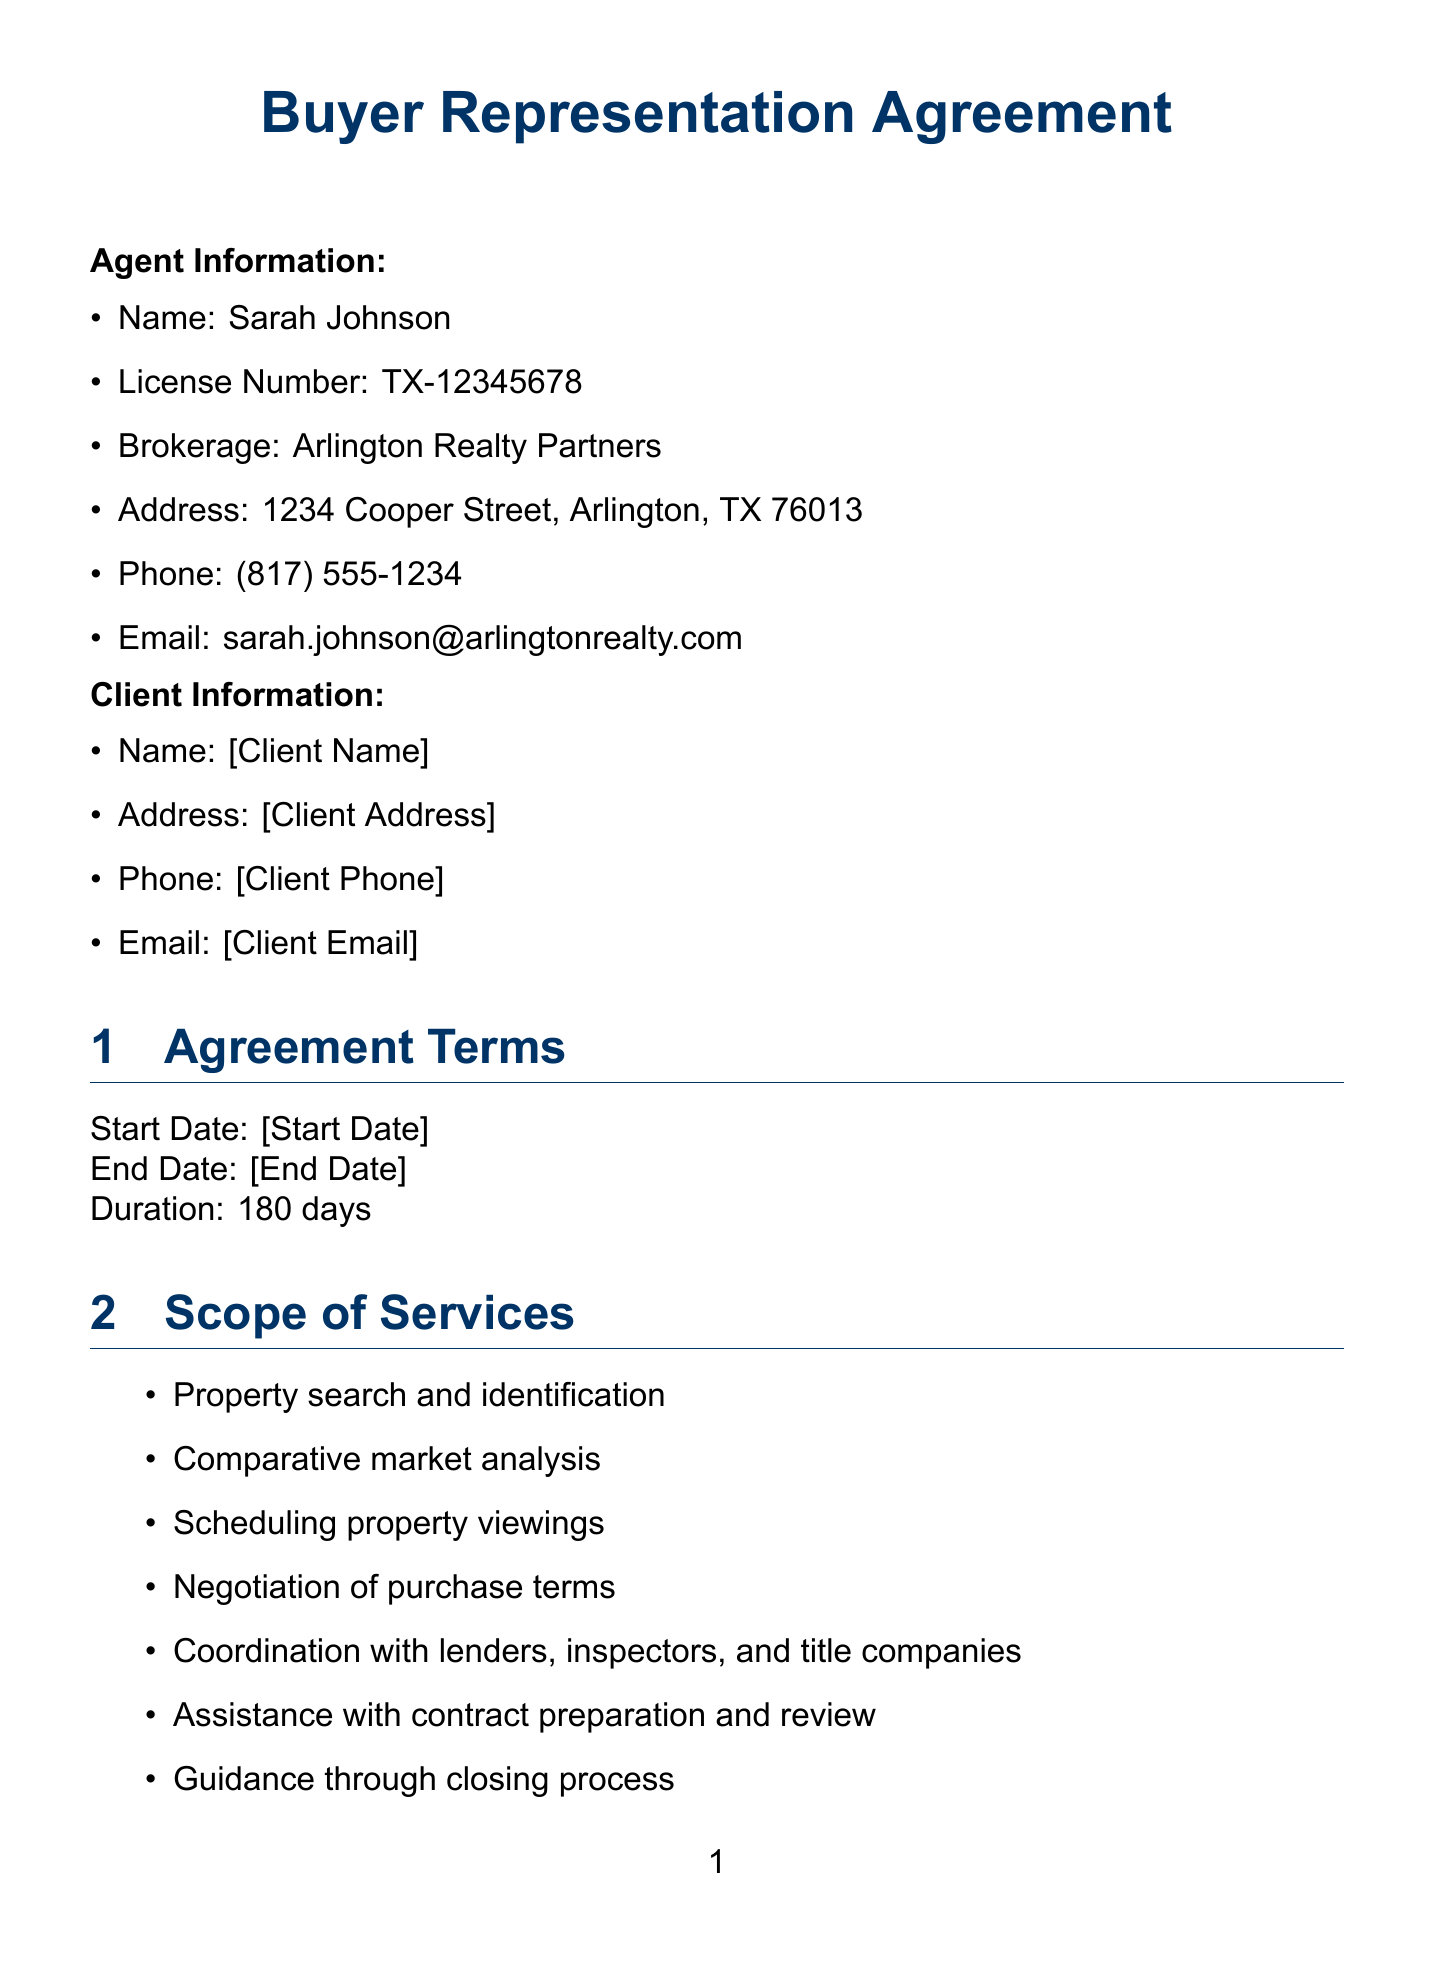What is the name of the agent? The document states that the agent representing the client is Sarah Johnson.
Answer: Sarah Johnson What is the duration of the agreement? The duration of the agreement is explicitly stated in the document as 180 days.
Answer: 180 days What services are included in the scope of services? The document lists several services including property search and identification and negotiation of purchase terms.
Answer: Property search and identification, Negotiation of purchase terms Is the exclusivity clause applicable? The document confirms that the client agrees to work exclusively with the named agent during the agreement term.
Answer: Yes What is the buyer agent fee percentage? The document clearly states that the buyer agent fee is 3 percent of the purchase price.
Answer: 3% How can the agreement be terminated? The document mentions that the agreement may be terminated by mutual consent or with 30 days written notice by either party.
Answer: Mutual consent or 30 days written notice What must the client do within 7 days of signing? The document stipulates that the client agrees to be pre-qualified for a mortgage within this timeframe.
Answer: Be pre-qualified for a mortgage What types of properties are included in the client's preferences? The document outlines that the preferred property types are single-family homes, townhouses, and condominiums.
Answer: Single-family home, Townhouse, Condominium What features does the client desire in a property? The document includes features such as a minimum of 3 bedrooms and at least 2 bathrooms as desired by the client.
Answer: Minimum 3 bedrooms, At least 2 bathrooms 